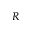Convert formula to latex. <formula><loc_0><loc_0><loc_500><loc_500>R</formula> 